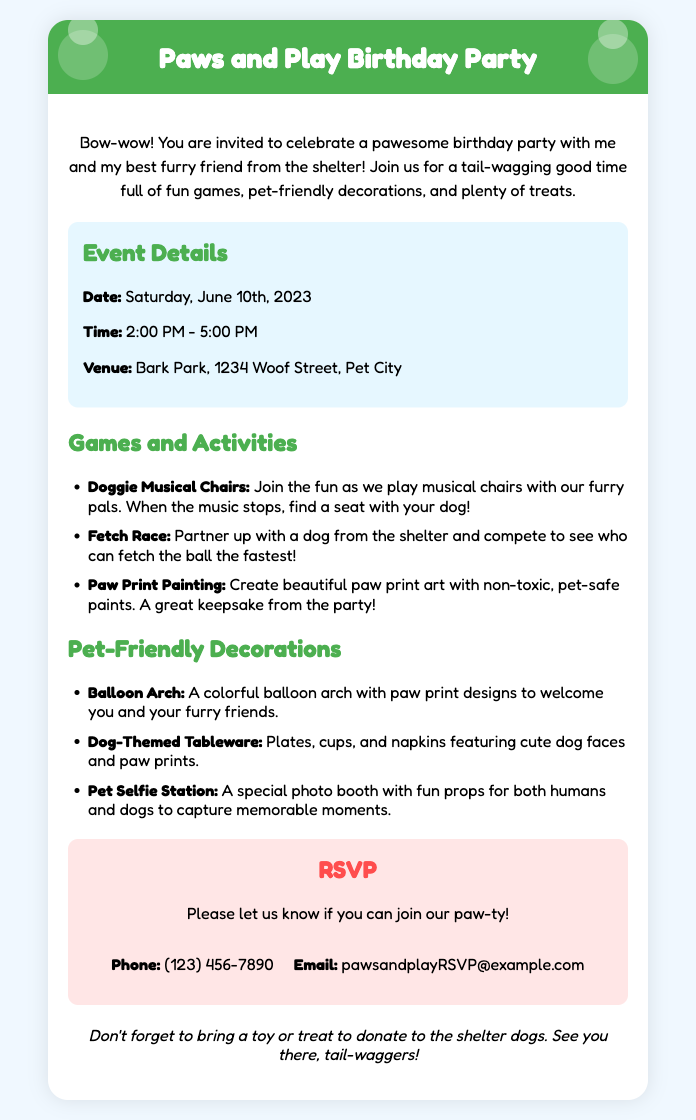What is the date of the birthday party? The date is clearly stated in the document under event details.
Answer: Saturday, June 10th, 2023 What time does the party start? The start time is mentioned in the event details section.
Answer: 2:00 PM Where is the venue located? The venue address is specified in the event details.
Answer: Bark Park, 1234 Woof Street, Pet City What is one of the games listed for the party? The games and activities section lists various games to participate in.
Answer: Doggie Musical Chairs What is the contact phone number for RSVP? The contact information for RSVPs includes a phone number.
Answer: (123) 456-7890 How long will the party last? The duration of the party can be calculated from the start and end times given in the document.
Answer: 3 hours What type of decorations are mentioned? The document specifies pet-friendly decorations in a dedicated section.
Answer: Balloon Arch What is requested to bring to the shelter? An extra note at the end of the document specifies what to bring.
Answer: A toy or treat What is the theme of the birthday party? The overall theme is introduced in the title and the introductory paragraph.
Answer: Dog-themed 